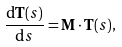<formula> <loc_0><loc_0><loc_500><loc_500>\frac { { \mathrm d } \mathbf T ( s ) } { { \mathrm d } s } = \mathbf M \cdot \mathbf T ( s ) ,</formula> 